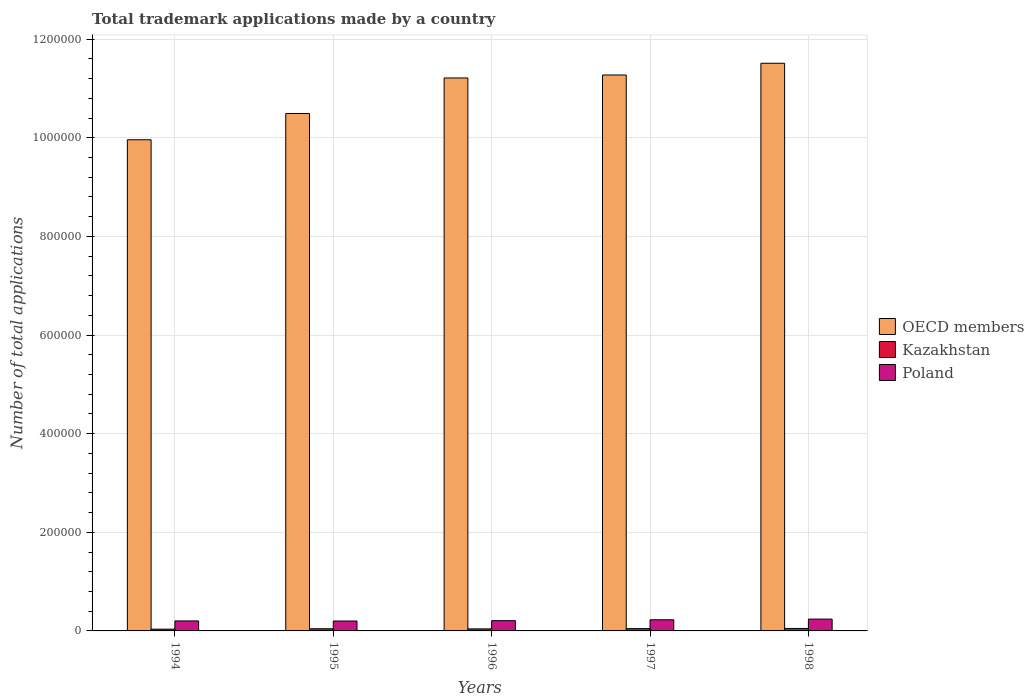How many different coloured bars are there?
Offer a terse response. 3. Are the number of bars on each tick of the X-axis equal?
Keep it short and to the point. Yes. How many bars are there on the 1st tick from the right?
Ensure brevity in your answer.  3. In how many cases, is the number of bars for a given year not equal to the number of legend labels?
Ensure brevity in your answer.  0. What is the number of applications made by in OECD members in 1997?
Give a very brief answer. 1.13e+06. Across all years, what is the maximum number of applications made by in Poland?
Keep it short and to the point. 2.40e+04. Across all years, what is the minimum number of applications made by in Poland?
Your answer should be compact. 2.01e+04. What is the total number of applications made by in OECD members in the graph?
Keep it short and to the point. 5.45e+06. What is the difference between the number of applications made by in Poland in 1994 and that in 1997?
Make the answer very short. -2357. What is the difference between the number of applications made by in Poland in 1994 and the number of applications made by in OECD members in 1995?
Your response must be concise. -1.03e+06. What is the average number of applications made by in Kazakhstan per year?
Ensure brevity in your answer.  4366. In the year 1994, what is the difference between the number of applications made by in Kazakhstan and number of applications made by in Poland?
Your answer should be compact. -1.67e+04. In how many years, is the number of applications made by in Kazakhstan greater than 120000?
Provide a short and direct response. 0. What is the ratio of the number of applications made by in Poland in 1994 to that in 1998?
Provide a short and direct response. 0.84. Is the number of applications made by in Poland in 1994 less than that in 1997?
Your response must be concise. Yes. What is the difference between the highest and the second highest number of applications made by in Poland?
Keep it short and to the point. 1378. What is the difference between the highest and the lowest number of applications made by in OECD members?
Ensure brevity in your answer.  1.55e+05. Is the sum of the number of applications made by in OECD members in 1995 and 1997 greater than the maximum number of applications made by in Poland across all years?
Make the answer very short. Yes. What does the 2nd bar from the left in 1995 represents?
Provide a succinct answer. Kazakhstan. What does the 2nd bar from the right in 1996 represents?
Offer a very short reply. Kazakhstan. How many years are there in the graph?
Give a very brief answer. 5. Are the values on the major ticks of Y-axis written in scientific E-notation?
Offer a terse response. No. Does the graph contain any zero values?
Your answer should be compact. No. How many legend labels are there?
Offer a terse response. 3. How are the legend labels stacked?
Make the answer very short. Vertical. What is the title of the graph?
Ensure brevity in your answer.  Total trademark applications made by a country. Does "Madagascar" appear as one of the legend labels in the graph?
Offer a terse response. No. What is the label or title of the Y-axis?
Make the answer very short. Number of total applications. What is the Number of total applications of OECD members in 1994?
Make the answer very short. 9.96e+05. What is the Number of total applications in Kazakhstan in 1994?
Ensure brevity in your answer.  3573. What is the Number of total applications of Poland in 1994?
Make the answer very short. 2.02e+04. What is the Number of total applications of OECD members in 1995?
Ensure brevity in your answer.  1.05e+06. What is the Number of total applications of Kazakhstan in 1995?
Give a very brief answer. 4411. What is the Number of total applications in Poland in 1995?
Your answer should be compact. 2.01e+04. What is the Number of total applications in OECD members in 1996?
Make the answer very short. 1.12e+06. What is the Number of total applications in Kazakhstan in 1996?
Offer a terse response. 4145. What is the Number of total applications of Poland in 1996?
Your answer should be very brief. 2.08e+04. What is the Number of total applications of OECD members in 1997?
Your response must be concise. 1.13e+06. What is the Number of total applications in Kazakhstan in 1997?
Your response must be concise. 4700. What is the Number of total applications in Poland in 1997?
Make the answer very short. 2.26e+04. What is the Number of total applications of OECD members in 1998?
Your answer should be compact. 1.15e+06. What is the Number of total applications of Kazakhstan in 1998?
Your answer should be compact. 5001. What is the Number of total applications of Poland in 1998?
Keep it short and to the point. 2.40e+04. Across all years, what is the maximum Number of total applications of OECD members?
Your answer should be compact. 1.15e+06. Across all years, what is the maximum Number of total applications of Kazakhstan?
Keep it short and to the point. 5001. Across all years, what is the maximum Number of total applications of Poland?
Provide a succinct answer. 2.40e+04. Across all years, what is the minimum Number of total applications of OECD members?
Offer a terse response. 9.96e+05. Across all years, what is the minimum Number of total applications in Kazakhstan?
Ensure brevity in your answer.  3573. Across all years, what is the minimum Number of total applications in Poland?
Your response must be concise. 2.01e+04. What is the total Number of total applications of OECD members in the graph?
Your response must be concise. 5.45e+06. What is the total Number of total applications of Kazakhstan in the graph?
Make the answer very short. 2.18e+04. What is the total Number of total applications in Poland in the graph?
Provide a succinct answer. 1.08e+05. What is the difference between the Number of total applications in OECD members in 1994 and that in 1995?
Keep it short and to the point. -5.33e+04. What is the difference between the Number of total applications of Kazakhstan in 1994 and that in 1995?
Your response must be concise. -838. What is the difference between the Number of total applications of Poland in 1994 and that in 1995?
Offer a very short reply. 138. What is the difference between the Number of total applications of OECD members in 1994 and that in 1996?
Make the answer very short. -1.25e+05. What is the difference between the Number of total applications in Kazakhstan in 1994 and that in 1996?
Your answer should be compact. -572. What is the difference between the Number of total applications of Poland in 1994 and that in 1996?
Your answer should be very brief. -572. What is the difference between the Number of total applications of OECD members in 1994 and that in 1997?
Your response must be concise. -1.31e+05. What is the difference between the Number of total applications in Kazakhstan in 1994 and that in 1997?
Ensure brevity in your answer.  -1127. What is the difference between the Number of total applications in Poland in 1994 and that in 1997?
Your answer should be compact. -2357. What is the difference between the Number of total applications in OECD members in 1994 and that in 1998?
Give a very brief answer. -1.55e+05. What is the difference between the Number of total applications of Kazakhstan in 1994 and that in 1998?
Make the answer very short. -1428. What is the difference between the Number of total applications in Poland in 1994 and that in 1998?
Your answer should be compact. -3735. What is the difference between the Number of total applications of OECD members in 1995 and that in 1996?
Provide a succinct answer. -7.20e+04. What is the difference between the Number of total applications in Kazakhstan in 1995 and that in 1996?
Give a very brief answer. 266. What is the difference between the Number of total applications in Poland in 1995 and that in 1996?
Provide a succinct answer. -710. What is the difference between the Number of total applications of OECD members in 1995 and that in 1997?
Your answer should be very brief. -7.80e+04. What is the difference between the Number of total applications in Kazakhstan in 1995 and that in 1997?
Provide a short and direct response. -289. What is the difference between the Number of total applications of Poland in 1995 and that in 1997?
Offer a very short reply. -2495. What is the difference between the Number of total applications in OECD members in 1995 and that in 1998?
Your answer should be compact. -1.02e+05. What is the difference between the Number of total applications of Kazakhstan in 1995 and that in 1998?
Give a very brief answer. -590. What is the difference between the Number of total applications in Poland in 1995 and that in 1998?
Ensure brevity in your answer.  -3873. What is the difference between the Number of total applications in OECD members in 1996 and that in 1997?
Ensure brevity in your answer.  -6000. What is the difference between the Number of total applications in Kazakhstan in 1996 and that in 1997?
Make the answer very short. -555. What is the difference between the Number of total applications in Poland in 1996 and that in 1997?
Your answer should be very brief. -1785. What is the difference between the Number of total applications in OECD members in 1996 and that in 1998?
Provide a short and direct response. -2.98e+04. What is the difference between the Number of total applications in Kazakhstan in 1996 and that in 1998?
Offer a terse response. -856. What is the difference between the Number of total applications in Poland in 1996 and that in 1998?
Give a very brief answer. -3163. What is the difference between the Number of total applications of OECD members in 1997 and that in 1998?
Give a very brief answer. -2.38e+04. What is the difference between the Number of total applications in Kazakhstan in 1997 and that in 1998?
Your response must be concise. -301. What is the difference between the Number of total applications of Poland in 1997 and that in 1998?
Keep it short and to the point. -1378. What is the difference between the Number of total applications of OECD members in 1994 and the Number of total applications of Kazakhstan in 1995?
Offer a terse response. 9.92e+05. What is the difference between the Number of total applications of OECD members in 1994 and the Number of total applications of Poland in 1995?
Your answer should be very brief. 9.76e+05. What is the difference between the Number of total applications of Kazakhstan in 1994 and the Number of total applications of Poland in 1995?
Make the answer very short. -1.65e+04. What is the difference between the Number of total applications of OECD members in 1994 and the Number of total applications of Kazakhstan in 1996?
Keep it short and to the point. 9.92e+05. What is the difference between the Number of total applications of OECD members in 1994 and the Number of total applications of Poland in 1996?
Give a very brief answer. 9.75e+05. What is the difference between the Number of total applications of Kazakhstan in 1994 and the Number of total applications of Poland in 1996?
Ensure brevity in your answer.  -1.72e+04. What is the difference between the Number of total applications of OECD members in 1994 and the Number of total applications of Kazakhstan in 1997?
Make the answer very short. 9.91e+05. What is the difference between the Number of total applications in OECD members in 1994 and the Number of total applications in Poland in 1997?
Provide a short and direct response. 9.73e+05. What is the difference between the Number of total applications of Kazakhstan in 1994 and the Number of total applications of Poland in 1997?
Ensure brevity in your answer.  -1.90e+04. What is the difference between the Number of total applications in OECD members in 1994 and the Number of total applications in Kazakhstan in 1998?
Your answer should be compact. 9.91e+05. What is the difference between the Number of total applications of OECD members in 1994 and the Number of total applications of Poland in 1998?
Ensure brevity in your answer.  9.72e+05. What is the difference between the Number of total applications of Kazakhstan in 1994 and the Number of total applications of Poland in 1998?
Keep it short and to the point. -2.04e+04. What is the difference between the Number of total applications of OECD members in 1995 and the Number of total applications of Kazakhstan in 1996?
Provide a succinct answer. 1.05e+06. What is the difference between the Number of total applications of OECD members in 1995 and the Number of total applications of Poland in 1996?
Your response must be concise. 1.03e+06. What is the difference between the Number of total applications of Kazakhstan in 1995 and the Number of total applications of Poland in 1996?
Offer a very short reply. -1.64e+04. What is the difference between the Number of total applications in OECD members in 1995 and the Number of total applications in Kazakhstan in 1997?
Offer a terse response. 1.04e+06. What is the difference between the Number of total applications in OECD members in 1995 and the Number of total applications in Poland in 1997?
Your answer should be compact. 1.03e+06. What is the difference between the Number of total applications in Kazakhstan in 1995 and the Number of total applications in Poland in 1997?
Your answer should be very brief. -1.82e+04. What is the difference between the Number of total applications in OECD members in 1995 and the Number of total applications in Kazakhstan in 1998?
Your response must be concise. 1.04e+06. What is the difference between the Number of total applications in OECD members in 1995 and the Number of total applications in Poland in 1998?
Provide a short and direct response. 1.03e+06. What is the difference between the Number of total applications of Kazakhstan in 1995 and the Number of total applications of Poland in 1998?
Give a very brief answer. -1.96e+04. What is the difference between the Number of total applications of OECD members in 1996 and the Number of total applications of Kazakhstan in 1997?
Make the answer very short. 1.12e+06. What is the difference between the Number of total applications in OECD members in 1996 and the Number of total applications in Poland in 1997?
Your response must be concise. 1.10e+06. What is the difference between the Number of total applications in Kazakhstan in 1996 and the Number of total applications in Poland in 1997?
Your response must be concise. -1.85e+04. What is the difference between the Number of total applications of OECD members in 1996 and the Number of total applications of Kazakhstan in 1998?
Make the answer very short. 1.12e+06. What is the difference between the Number of total applications in OECD members in 1996 and the Number of total applications in Poland in 1998?
Provide a succinct answer. 1.10e+06. What is the difference between the Number of total applications of Kazakhstan in 1996 and the Number of total applications of Poland in 1998?
Keep it short and to the point. -1.98e+04. What is the difference between the Number of total applications of OECD members in 1997 and the Number of total applications of Kazakhstan in 1998?
Keep it short and to the point. 1.12e+06. What is the difference between the Number of total applications of OECD members in 1997 and the Number of total applications of Poland in 1998?
Your answer should be very brief. 1.10e+06. What is the difference between the Number of total applications in Kazakhstan in 1997 and the Number of total applications in Poland in 1998?
Give a very brief answer. -1.93e+04. What is the average Number of total applications in OECD members per year?
Offer a very short reply. 1.09e+06. What is the average Number of total applications in Kazakhstan per year?
Give a very brief answer. 4366. What is the average Number of total applications in Poland per year?
Your answer should be very brief. 2.16e+04. In the year 1994, what is the difference between the Number of total applications in OECD members and Number of total applications in Kazakhstan?
Provide a succinct answer. 9.92e+05. In the year 1994, what is the difference between the Number of total applications in OECD members and Number of total applications in Poland?
Provide a short and direct response. 9.76e+05. In the year 1994, what is the difference between the Number of total applications of Kazakhstan and Number of total applications of Poland?
Provide a short and direct response. -1.67e+04. In the year 1995, what is the difference between the Number of total applications of OECD members and Number of total applications of Kazakhstan?
Offer a terse response. 1.04e+06. In the year 1995, what is the difference between the Number of total applications of OECD members and Number of total applications of Poland?
Give a very brief answer. 1.03e+06. In the year 1995, what is the difference between the Number of total applications of Kazakhstan and Number of total applications of Poland?
Offer a very short reply. -1.57e+04. In the year 1996, what is the difference between the Number of total applications of OECD members and Number of total applications of Kazakhstan?
Your answer should be compact. 1.12e+06. In the year 1996, what is the difference between the Number of total applications in OECD members and Number of total applications in Poland?
Ensure brevity in your answer.  1.10e+06. In the year 1996, what is the difference between the Number of total applications in Kazakhstan and Number of total applications in Poland?
Ensure brevity in your answer.  -1.67e+04. In the year 1997, what is the difference between the Number of total applications of OECD members and Number of total applications of Kazakhstan?
Ensure brevity in your answer.  1.12e+06. In the year 1997, what is the difference between the Number of total applications of OECD members and Number of total applications of Poland?
Keep it short and to the point. 1.10e+06. In the year 1997, what is the difference between the Number of total applications of Kazakhstan and Number of total applications of Poland?
Offer a terse response. -1.79e+04. In the year 1998, what is the difference between the Number of total applications in OECD members and Number of total applications in Kazakhstan?
Provide a short and direct response. 1.15e+06. In the year 1998, what is the difference between the Number of total applications of OECD members and Number of total applications of Poland?
Your answer should be very brief. 1.13e+06. In the year 1998, what is the difference between the Number of total applications of Kazakhstan and Number of total applications of Poland?
Provide a succinct answer. -1.90e+04. What is the ratio of the Number of total applications in OECD members in 1994 to that in 1995?
Ensure brevity in your answer.  0.95. What is the ratio of the Number of total applications of Kazakhstan in 1994 to that in 1995?
Your answer should be compact. 0.81. What is the ratio of the Number of total applications of OECD members in 1994 to that in 1996?
Your answer should be compact. 0.89. What is the ratio of the Number of total applications of Kazakhstan in 1994 to that in 1996?
Your answer should be compact. 0.86. What is the ratio of the Number of total applications in Poland in 1994 to that in 1996?
Offer a terse response. 0.97. What is the ratio of the Number of total applications in OECD members in 1994 to that in 1997?
Ensure brevity in your answer.  0.88. What is the ratio of the Number of total applications in Kazakhstan in 1994 to that in 1997?
Give a very brief answer. 0.76. What is the ratio of the Number of total applications in Poland in 1994 to that in 1997?
Give a very brief answer. 0.9. What is the ratio of the Number of total applications of OECD members in 1994 to that in 1998?
Make the answer very short. 0.87. What is the ratio of the Number of total applications in Kazakhstan in 1994 to that in 1998?
Provide a short and direct response. 0.71. What is the ratio of the Number of total applications of Poland in 1994 to that in 1998?
Make the answer very short. 0.84. What is the ratio of the Number of total applications of OECD members in 1995 to that in 1996?
Ensure brevity in your answer.  0.94. What is the ratio of the Number of total applications of Kazakhstan in 1995 to that in 1996?
Make the answer very short. 1.06. What is the ratio of the Number of total applications in Poland in 1995 to that in 1996?
Offer a terse response. 0.97. What is the ratio of the Number of total applications of OECD members in 1995 to that in 1997?
Your response must be concise. 0.93. What is the ratio of the Number of total applications of Kazakhstan in 1995 to that in 1997?
Your answer should be very brief. 0.94. What is the ratio of the Number of total applications of Poland in 1995 to that in 1997?
Make the answer very short. 0.89. What is the ratio of the Number of total applications of OECD members in 1995 to that in 1998?
Offer a very short reply. 0.91. What is the ratio of the Number of total applications of Kazakhstan in 1995 to that in 1998?
Keep it short and to the point. 0.88. What is the ratio of the Number of total applications in Poland in 1995 to that in 1998?
Your response must be concise. 0.84. What is the ratio of the Number of total applications in OECD members in 1996 to that in 1997?
Make the answer very short. 0.99. What is the ratio of the Number of total applications of Kazakhstan in 1996 to that in 1997?
Ensure brevity in your answer.  0.88. What is the ratio of the Number of total applications in Poland in 1996 to that in 1997?
Give a very brief answer. 0.92. What is the ratio of the Number of total applications in OECD members in 1996 to that in 1998?
Offer a terse response. 0.97. What is the ratio of the Number of total applications in Kazakhstan in 1996 to that in 1998?
Make the answer very short. 0.83. What is the ratio of the Number of total applications in Poland in 1996 to that in 1998?
Make the answer very short. 0.87. What is the ratio of the Number of total applications in OECD members in 1997 to that in 1998?
Make the answer very short. 0.98. What is the ratio of the Number of total applications of Kazakhstan in 1997 to that in 1998?
Ensure brevity in your answer.  0.94. What is the ratio of the Number of total applications in Poland in 1997 to that in 1998?
Make the answer very short. 0.94. What is the difference between the highest and the second highest Number of total applications in OECD members?
Your answer should be compact. 2.38e+04. What is the difference between the highest and the second highest Number of total applications of Kazakhstan?
Provide a succinct answer. 301. What is the difference between the highest and the second highest Number of total applications in Poland?
Your response must be concise. 1378. What is the difference between the highest and the lowest Number of total applications in OECD members?
Offer a very short reply. 1.55e+05. What is the difference between the highest and the lowest Number of total applications in Kazakhstan?
Offer a terse response. 1428. What is the difference between the highest and the lowest Number of total applications of Poland?
Your answer should be very brief. 3873. 